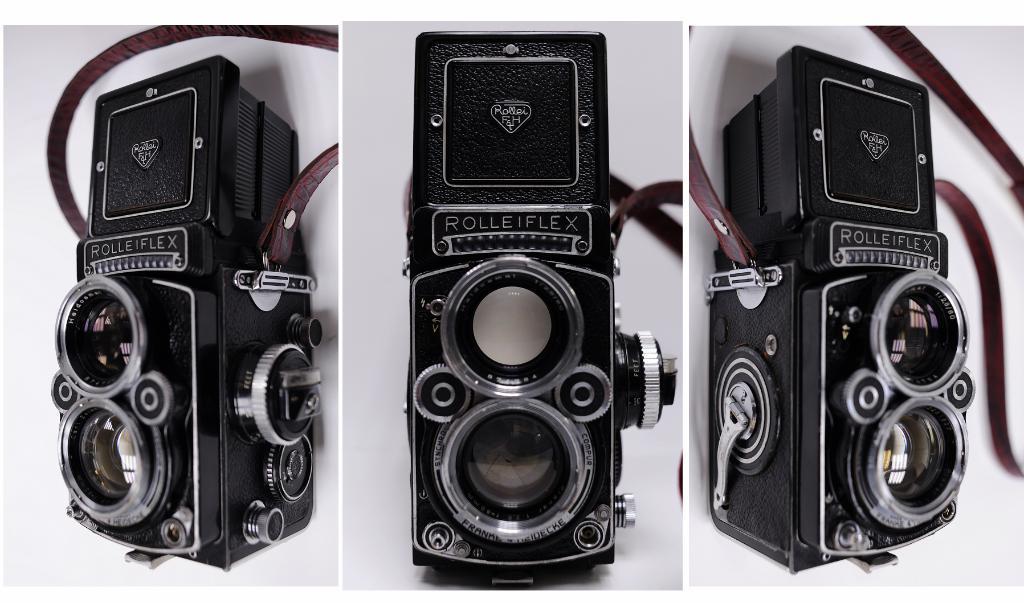Please provide a concise description of this image. In this image I can see three objects and a white color background. This image is taken may be in a hall. 